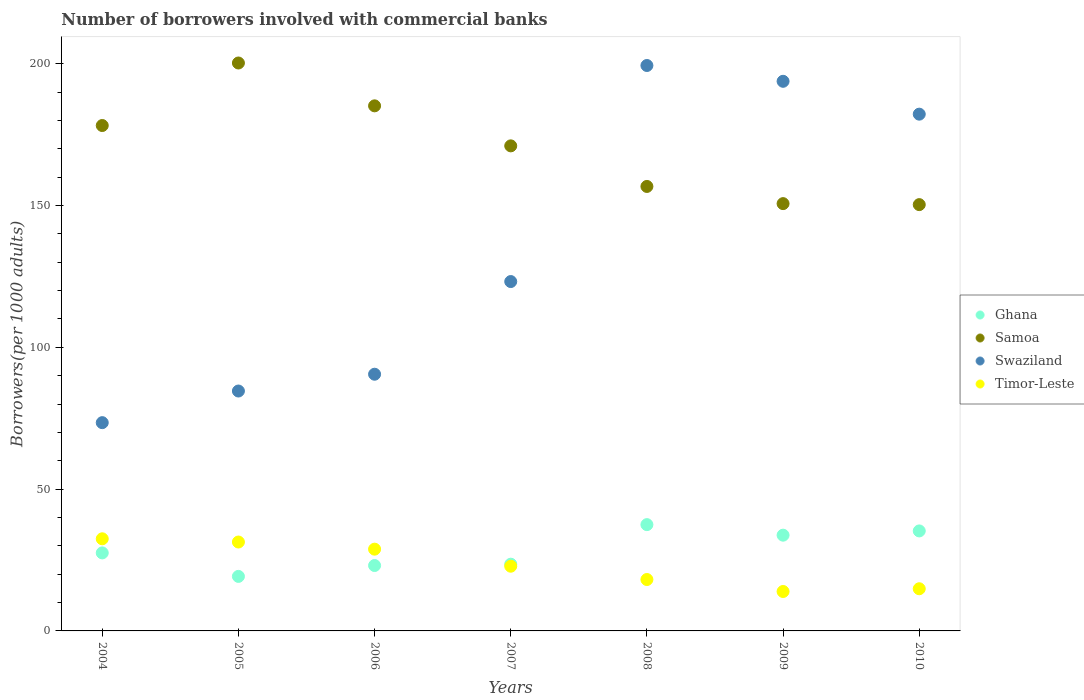How many different coloured dotlines are there?
Offer a very short reply. 4. Is the number of dotlines equal to the number of legend labels?
Give a very brief answer. Yes. What is the number of borrowers involved with commercial banks in Ghana in 2005?
Ensure brevity in your answer.  19.23. Across all years, what is the maximum number of borrowers involved with commercial banks in Timor-Leste?
Keep it short and to the point. 32.48. Across all years, what is the minimum number of borrowers involved with commercial banks in Ghana?
Your answer should be very brief. 19.23. In which year was the number of borrowers involved with commercial banks in Timor-Leste maximum?
Provide a succinct answer. 2004. What is the total number of borrowers involved with commercial banks in Swaziland in the graph?
Offer a very short reply. 947.16. What is the difference between the number of borrowers involved with commercial banks in Timor-Leste in 2005 and that in 2006?
Your answer should be compact. 2.52. What is the difference between the number of borrowers involved with commercial banks in Ghana in 2004 and the number of borrowers involved with commercial banks in Timor-Leste in 2008?
Your answer should be very brief. 9.39. What is the average number of borrowers involved with commercial banks in Timor-Leste per year?
Your answer should be very brief. 23.2. In the year 2010, what is the difference between the number of borrowers involved with commercial banks in Samoa and number of borrowers involved with commercial banks in Swaziland?
Keep it short and to the point. -31.9. In how many years, is the number of borrowers involved with commercial banks in Swaziland greater than 100?
Keep it short and to the point. 4. What is the ratio of the number of borrowers involved with commercial banks in Samoa in 2004 to that in 2010?
Provide a short and direct response. 1.19. Is the number of borrowers involved with commercial banks in Ghana in 2005 less than that in 2006?
Your answer should be compact. Yes. Is the difference between the number of borrowers involved with commercial banks in Samoa in 2007 and 2010 greater than the difference between the number of borrowers involved with commercial banks in Swaziland in 2007 and 2010?
Give a very brief answer. Yes. What is the difference between the highest and the second highest number of borrowers involved with commercial banks in Ghana?
Make the answer very short. 2.22. What is the difference between the highest and the lowest number of borrowers involved with commercial banks in Samoa?
Your answer should be very brief. 49.94. In how many years, is the number of borrowers involved with commercial banks in Swaziland greater than the average number of borrowers involved with commercial banks in Swaziland taken over all years?
Make the answer very short. 3. Is the sum of the number of borrowers involved with commercial banks in Timor-Leste in 2004 and 2010 greater than the maximum number of borrowers involved with commercial banks in Swaziland across all years?
Provide a short and direct response. No. Does the number of borrowers involved with commercial banks in Ghana monotonically increase over the years?
Your answer should be very brief. No. How many dotlines are there?
Your answer should be compact. 4. How many years are there in the graph?
Your response must be concise. 7. What is the difference between two consecutive major ticks on the Y-axis?
Provide a succinct answer. 50. Does the graph contain any zero values?
Your answer should be very brief. No. How many legend labels are there?
Give a very brief answer. 4. How are the legend labels stacked?
Your answer should be compact. Vertical. What is the title of the graph?
Keep it short and to the point. Number of borrowers involved with commercial banks. Does "Bulgaria" appear as one of the legend labels in the graph?
Your answer should be very brief. No. What is the label or title of the Y-axis?
Keep it short and to the point. Borrowers(per 1000 adults). What is the Borrowers(per 1000 adults) in Ghana in 2004?
Your answer should be very brief. 27.51. What is the Borrowers(per 1000 adults) in Samoa in 2004?
Provide a succinct answer. 178.22. What is the Borrowers(per 1000 adults) of Swaziland in 2004?
Keep it short and to the point. 73.44. What is the Borrowers(per 1000 adults) in Timor-Leste in 2004?
Provide a short and direct response. 32.48. What is the Borrowers(per 1000 adults) of Ghana in 2005?
Provide a succinct answer. 19.23. What is the Borrowers(per 1000 adults) in Samoa in 2005?
Keep it short and to the point. 200.26. What is the Borrowers(per 1000 adults) in Swaziland in 2005?
Make the answer very short. 84.59. What is the Borrowers(per 1000 adults) in Timor-Leste in 2005?
Offer a terse response. 31.35. What is the Borrowers(per 1000 adults) in Ghana in 2006?
Offer a terse response. 23.06. What is the Borrowers(per 1000 adults) in Samoa in 2006?
Provide a short and direct response. 185.16. What is the Borrowers(per 1000 adults) in Swaziland in 2006?
Ensure brevity in your answer.  90.52. What is the Borrowers(per 1000 adults) of Timor-Leste in 2006?
Give a very brief answer. 28.83. What is the Borrowers(per 1000 adults) of Ghana in 2007?
Offer a terse response. 23.53. What is the Borrowers(per 1000 adults) of Samoa in 2007?
Offer a very short reply. 171.04. What is the Borrowers(per 1000 adults) of Swaziland in 2007?
Make the answer very short. 123.19. What is the Borrowers(per 1000 adults) in Timor-Leste in 2007?
Your response must be concise. 22.82. What is the Borrowers(per 1000 adults) in Ghana in 2008?
Keep it short and to the point. 37.48. What is the Borrowers(per 1000 adults) in Samoa in 2008?
Provide a short and direct response. 156.73. What is the Borrowers(per 1000 adults) in Swaziland in 2008?
Your answer should be very brief. 199.38. What is the Borrowers(per 1000 adults) in Timor-Leste in 2008?
Your answer should be very brief. 18.13. What is the Borrowers(per 1000 adults) in Ghana in 2009?
Ensure brevity in your answer.  33.76. What is the Borrowers(per 1000 adults) in Samoa in 2009?
Ensure brevity in your answer.  150.68. What is the Borrowers(per 1000 adults) of Swaziland in 2009?
Your response must be concise. 193.81. What is the Borrowers(per 1000 adults) in Timor-Leste in 2009?
Give a very brief answer. 13.9. What is the Borrowers(per 1000 adults) of Ghana in 2010?
Make the answer very short. 35.26. What is the Borrowers(per 1000 adults) in Samoa in 2010?
Provide a short and direct response. 150.32. What is the Borrowers(per 1000 adults) in Swaziland in 2010?
Make the answer very short. 182.22. What is the Borrowers(per 1000 adults) in Timor-Leste in 2010?
Your answer should be very brief. 14.87. Across all years, what is the maximum Borrowers(per 1000 adults) of Ghana?
Your response must be concise. 37.48. Across all years, what is the maximum Borrowers(per 1000 adults) of Samoa?
Offer a terse response. 200.26. Across all years, what is the maximum Borrowers(per 1000 adults) in Swaziland?
Your response must be concise. 199.38. Across all years, what is the maximum Borrowers(per 1000 adults) in Timor-Leste?
Offer a very short reply. 32.48. Across all years, what is the minimum Borrowers(per 1000 adults) of Ghana?
Offer a terse response. 19.23. Across all years, what is the minimum Borrowers(per 1000 adults) of Samoa?
Give a very brief answer. 150.32. Across all years, what is the minimum Borrowers(per 1000 adults) of Swaziland?
Your answer should be compact. 73.44. Across all years, what is the minimum Borrowers(per 1000 adults) of Timor-Leste?
Your answer should be very brief. 13.9. What is the total Borrowers(per 1000 adults) of Ghana in the graph?
Offer a very short reply. 199.83. What is the total Borrowers(per 1000 adults) in Samoa in the graph?
Make the answer very short. 1192.41. What is the total Borrowers(per 1000 adults) of Swaziland in the graph?
Make the answer very short. 947.16. What is the total Borrowers(per 1000 adults) of Timor-Leste in the graph?
Offer a very short reply. 162.38. What is the difference between the Borrowers(per 1000 adults) in Ghana in 2004 and that in 2005?
Offer a terse response. 8.29. What is the difference between the Borrowers(per 1000 adults) of Samoa in 2004 and that in 2005?
Give a very brief answer. -22.05. What is the difference between the Borrowers(per 1000 adults) in Swaziland in 2004 and that in 2005?
Ensure brevity in your answer.  -11.15. What is the difference between the Borrowers(per 1000 adults) of Timor-Leste in 2004 and that in 2005?
Make the answer very short. 1.14. What is the difference between the Borrowers(per 1000 adults) of Ghana in 2004 and that in 2006?
Keep it short and to the point. 4.45. What is the difference between the Borrowers(per 1000 adults) of Samoa in 2004 and that in 2006?
Provide a short and direct response. -6.94. What is the difference between the Borrowers(per 1000 adults) of Swaziland in 2004 and that in 2006?
Your response must be concise. -17.08. What is the difference between the Borrowers(per 1000 adults) in Timor-Leste in 2004 and that in 2006?
Give a very brief answer. 3.65. What is the difference between the Borrowers(per 1000 adults) of Ghana in 2004 and that in 2007?
Provide a short and direct response. 3.99. What is the difference between the Borrowers(per 1000 adults) in Samoa in 2004 and that in 2007?
Offer a terse response. 7.17. What is the difference between the Borrowers(per 1000 adults) of Swaziland in 2004 and that in 2007?
Keep it short and to the point. -49.75. What is the difference between the Borrowers(per 1000 adults) in Timor-Leste in 2004 and that in 2007?
Offer a very short reply. 9.66. What is the difference between the Borrowers(per 1000 adults) of Ghana in 2004 and that in 2008?
Your answer should be very brief. -9.97. What is the difference between the Borrowers(per 1000 adults) of Samoa in 2004 and that in 2008?
Your answer should be very brief. 21.48. What is the difference between the Borrowers(per 1000 adults) of Swaziland in 2004 and that in 2008?
Provide a succinct answer. -125.94. What is the difference between the Borrowers(per 1000 adults) of Timor-Leste in 2004 and that in 2008?
Your response must be concise. 14.36. What is the difference between the Borrowers(per 1000 adults) in Ghana in 2004 and that in 2009?
Offer a very short reply. -6.25. What is the difference between the Borrowers(per 1000 adults) in Samoa in 2004 and that in 2009?
Give a very brief answer. 27.54. What is the difference between the Borrowers(per 1000 adults) in Swaziland in 2004 and that in 2009?
Your answer should be very brief. -120.37. What is the difference between the Borrowers(per 1000 adults) of Timor-Leste in 2004 and that in 2009?
Your response must be concise. 18.58. What is the difference between the Borrowers(per 1000 adults) of Ghana in 2004 and that in 2010?
Your answer should be very brief. -7.75. What is the difference between the Borrowers(per 1000 adults) in Samoa in 2004 and that in 2010?
Give a very brief answer. 27.89. What is the difference between the Borrowers(per 1000 adults) of Swaziland in 2004 and that in 2010?
Your answer should be compact. -108.78. What is the difference between the Borrowers(per 1000 adults) of Timor-Leste in 2004 and that in 2010?
Provide a succinct answer. 17.61. What is the difference between the Borrowers(per 1000 adults) in Ghana in 2005 and that in 2006?
Provide a succinct answer. -3.84. What is the difference between the Borrowers(per 1000 adults) in Samoa in 2005 and that in 2006?
Offer a very short reply. 15.11. What is the difference between the Borrowers(per 1000 adults) in Swaziland in 2005 and that in 2006?
Provide a succinct answer. -5.92. What is the difference between the Borrowers(per 1000 adults) in Timor-Leste in 2005 and that in 2006?
Offer a very short reply. 2.52. What is the difference between the Borrowers(per 1000 adults) of Ghana in 2005 and that in 2007?
Ensure brevity in your answer.  -4.3. What is the difference between the Borrowers(per 1000 adults) of Samoa in 2005 and that in 2007?
Keep it short and to the point. 29.22. What is the difference between the Borrowers(per 1000 adults) in Swaziland in 2005 and that in 2007?
Your response must be concise. -38.6. What is the difference between the Borrowers(per 1000 adults) of Timor-Leste in 2005 and that in 2007?
Your response must be concise. 8.53. What is the difference between the Borrowers(per 1000 adults) in Ghana in 2005 and that in 2008?
Make the answer very short. -18.26. What is the difference between the Borrowers(per 1000 adults) of Samoa in 2005 and that in 2008?
Offer a terse response. 43.53. What is the difference between the Borrowers(per 1000 adults) of Swaziland in 2005 and that in 2008?
Offer a very short reply. -114.79. What is the difference between the Borrowers(per 1000 adults) in Timor-Leste in 2005 and that in 2008?
Your answer should be very brief. 13.22. What is the difference between the Borrowers(per 1000 adults) in Ghana in 2005 and that in 2009?
Give a very brief answer. -14.54. What is the difference between the Borrowers(per 1000 adults) of Samoa in 2005 and that in 2009?
Provide a short and direct response. 49.59. What is the difference between the Borrowers(per 1000 adults) of Swaziland in 2005 and that in 2009?
Provide a succinct answer. -109.22. What is the difference between the Borrowers(per 1000 adults) in Timor-Leste in 2005 and that in 2009?
Give a very brief answer. 17.45. What is the difference between the Borrowers(per 1000 adults) in Ghana in 2005 and that in 2010?
Keep it short and to the point. -16.03. What is the difference between the Borrowers(per 1000 adults) in Samoa in 2005 and that in 2010?
Give a very brief answer. 49.94. What is the difference between the Borrowers(per 1000 adults) in Swaziland in 2005 and that in 2010?
Give a very brief answer. -97.63. What is the difference between the Borrowers(per 1000 adults) of Timor-Leste in 2005 and that in 2010?
Your response must be concise. 16.48. What is the difference between the Borrowers(per 1000 adults) in Ghana in 2006 and that in 2007?
Your response must be concise. -0.46. What is the difference between the Borrowers(per 1000 adults) in Samoa in 2006 and that in 2007?
Your answer should be very brief. 14.11. What is the difference between the Borrowers(per 1000 adults) in Swaziland in 2006 and that in 2007?
Your answer should be compact. -32.68. What is the difference between the Borrowers(per 1000 adults) of Timor-Leste in 2006 and that in 2007?
Ensure brevity in your answer.  6.01. What is the difference between the Borrowers(per 1000 adults) in Ghana in 2006 and that in 2008?
Provide a succinct answer. -14.42. What is the difference between the Borrowers(per 1000 adults) of Samoa in 2006 and that in 2008?
Your answer should be very brief. 28.42. What is the difference between the Borrowers(per 1000 adults) of Swaziland in 2006 and that in 2008?
Your answer should be compact. -108.86. What is the difference between the Borrowers(per 1000 adults) in Timor-Leste in 2006 and that in 2008?
Provide a short and direct response. 10.71. What is the difference between the Borrowers(per 1000 adults) in Ghana in 2006 and that in 2009?
Your answer should be compact. -10.7. What is the difference between the Borrowers(per 1000 adults) in Samoa in 2006 and that in 2009?
Provide a short and direct response. 34.48. What is the difference between the Borrowers(per 1000 adults) of Swaziland in 2006 and that in 2009?
Make the answer very short. -103.29. What is the difference between the Borrowers(per 1000 adults) in Timor-Leste in 2006 and that in 2009?
Offer a very short reply. 14.93. What is the difference between the Borrowers(per 1000 adults) in Ghana in 2006 and that in 2010?
Your answer should be very brief. -12.2. What is the difference between the Borrowers(per 1000 adults) in Samoa in 2006 and that in 2010?
Your response must be concise. 34.83. What is the difference between the Borrowers(per 1000 adults) in Swaziland in 2006 and that in 2010?
Your answer should be compact. -91.7. What is the difference between the Borrowers(per 1000 adults) in Timor-Leste in 2006 and that in 2010?
Ensure brevity in your answer.  13.96. What is the difference between the Borrowers(per 1000 adults) of Ghana in 2007 and that in 2008?
Make the answer very short. -13.96. What is the difference between the Borrowers(per 1000 adults) of Samoa in 2007 and that in 2008?
Your answer should be very brief. 14.31. What is the difference between the Borrowers(per 1000 adults) of Swaziland in 2007 and that in 2008?
Keep it short and to the point. -76.19. What is the difference between the Borrowers(per 1000 adults) of Timor-Leste in 2007 and that in 2008?
Provide a succinct answer. 4.69. What is the difference between the Borrowers(per 1000 adults) of Ghana in 2007 and that in 2009?
Your response must be concise. -10.24. What is the difference between the Borrowers(per 1000 adults) of Samoa in 2007 and that in 2009?
Provide a succinct answer. 20.37. What is the difference between the Borrowers(per 1000 adults) of Swaziland in 2007 and that in 2009?
Offer a very short reply. -70.62. What is the difference between the Borrowers(per 1000 adults) of Timor-Leste in 2007 and that in 2009?
Keep it short and to the point. 8.92. What is the difference between the Borrowers(per 1000 adults) in Ghana in 2007 and that in 2010?
Your answer should be very brief. -11.73. What is the difference between the Borrowers(per 1000 adults) in Samoa in 2007 and that in 2010?
Your answer should be very brief. 20.72. What is the difference between the Borrowers(per 1000 adults) in Swaziland in 2007 and that in 2010?
Make the answer very short. -59.03. What is the difference between the Borrowers(per 1000 adults) of Timor-Leste in 2007 and that in 2010?
Keep it short and to the point. 7.95. What is the difference between the Borrowers(per 1000 adults) in Ghana in 2008 and that in 2009?
Give a very brief answer. 3.72. What is the difference between the Borrowers(per 1000 adults) in Samoa in 2008 and that in 2009?
Provide a short and direct response. 6.06. What is the difference between the Borrowers(per 1000 adults) of Swaziland in 2008 and that in 2009?
Give a very brief answer. 5.57. What is the difference between the Borrowers(per 1000 adults) of Timor-Leste in 2008 and that in 2009?
Your answer should be compact. 4.22. What is the difference between the Borrowers(per 1000 adults) in Ghana in 2008 and that in 2010?
Keep it short and to the point. 2.22. What is the difference between the Borrowers(per 1000 adults) in Samoa in 2008 and that in 2010?
Give a very brief answer. 6.41. What is the difference between the Borrowers(per 1000 adults) of Swaziland in 2008 and that in 2010?
Offer a terse response. 17.16. What is the difference between the Borrowers(per 1000 adults) of Timor-Leste in 2008 and that in 2010?
Your answer should be very brief. 3.25. What is the difference between the Borrowers(per 1000 adults) of Ghana in 2009 and that in 2010?
Provide a succinct answer. -1.5. What is the difference between the Borrowers(per 1000 adults) of Samoa in 2009 and that in 2010?
Keep it short and to the point. 0.35. What is the difference between the Borrowers(per 1000 adults) in Swaziland in 2009 and that in 2010?
Ensure brevity in your answer.  11.59. What is the difference between the Borrowers(per 1000 adults) in Timor-Leste in 2009 and that in 2010?
Keep it short and to the point. -0.97. What is the difference between the Borrowers(per 1000 adults) in Ghana in 2004 and the Borrowers(per 1000 adults) in Samoa in 2005?
Give a very brief answer. -172.75. What is the difference between the Borrowers(per 1000 adults) of Ghana in 2004 and the Borrowers(per 1000 adults) of Swaziland in 2005?
Provide a short and direct response. -57.08. What is the difference between the Borrowers(per 1000 adults) of Ghana in 2004 and the Borrowers(per 1000 adults) of Timor-Leste in 2005?
Provide a short and direct response. -3.83. What is the difference between the Borrowers(per 1000 adults) of Samoa in 2004 and the Borrowers(per 1000 adults) of Swaziland in 2005?
Your answer should be compact. 93.62. What is the difference between the Borrowers(per 1000 adults) of Samoa in 2004 and the Borrowers(per 1000 adults) of Timor-Leste in 2005?
Provide a short and direct response. 146.87. What is the difference between the Borrowers(per 1000 adults) of Swaziland in 2004 and the Borrowers(per 1000 adults) of Timor-Leste in 2005?
Provide a short and direct response. 42.09. What is the difference between the Borrowers(per 1000 adults) of Ghana in 2004 and the Borrowers(per 1000 adults) of Samoa in 2006?
Your response must be concise. -157.64. What is the difference between the Borrowers(per 1000 adults) of Ghana in 2004 and the Borrowers(per 1000 adults) of Swaziland in 2006?
Offer a very short reply. -63. What is the difference between the Borrowers(per 1000 adults) of Ghana in 2004 and the Borrowers(per 1000 adults) of Timor-Leste in 2006?
Offer a terse response. -1.32. What is the difference between the Borrowers(per 1000 adults) in Samoa in 2004 and the Borrowers(per 1000 adults) in Swaziland in 2006?
Make the answer very short. 87.7. What is the difference between the Borrowers(per 1000 adults) in Samoa in 2004 and the Borrowers(per 1000 adults) in Timor-Leste in 2006?
Keep it short and to the point. 149.38. What is the difference between the Borrowers(per 1000 adults) of Swaziland in 2004 and the Borrowers(per 1000 adults) of Timor-Leste in 2006?
Offer a terse response. 44.61. What is the difference between the Borrowers(per 1000 adults) in Ghana in 2004 and the Borrowers(per 1000 adults) in Samoa in 2007?
Ensure brevity in your answer.  -143.53. What is the difference between the Borrowers(per 1000 adults) of Ghana in 2004 and the Borrowers(per 1000 adults) of Swaziland in 2007?
Keep it short and to the point. -95.68. What is the difference between the Borrowers(per 1000 adults) of Ghana in 2004 and the Borrowers(per 1000 adults) of Timor-Leste in 2007?
Ensure brevity in your answer.  4.69. What is the difference between the Borrowers(per 1000 adults) of Samoa in 2004 and the Borrowers(per 1000 adults) of Swaziland in 2007?
Provide a short and direct response. 55.02. What is the difference between the Borrowers(per 1000 adults) of Samoa in 2004 and the Borrowers(per 1000 adults) of Timor-Leste in 2007?
Your answer should be compact. 155.4. What is the difference between the Borrowers(per 1000 adults) of Swaziland in 2004 and the Borrowers(per 1000 adults) of Timor-Leste in 2007?
Make the answer very short. 50.62. What is the difference between the Borrowers(per 1000 adults) in Ghana in 2004 and the Borrowers(per 1000 adults) in Samoa in 2008?
Your response must be concise. -129.22. What is the difference between the Borrowers(per 1000 adults) of Ghana in 2004 and the Borrowers(per 1000 adults) of Swaziland in 2008?
Provide a succinct answer. -171.87. What is the difference between the Borrowers(per 1000 adults) in Ghana in 2004 and the Borrowers(per 1000 adults) in Timor-Leste in 2008?
Keep it short and to the point. 9.39. What is the difference between the Borrowers(per 1000 adults) of Samoa in 2004 and the Borrowers(per 1000 adults) of Swaziland in 2008?
Keep it short and to the point. -21.17. What is the difference between the Borrowers(per 1000 adults) in Samoa in 2004 and the Borrowers(per 1000 adults) in Timor-Leste in 2008?
Your answer should be very brief. 160.09. What is the difference between the Borrowers(per 1000 adults) of Swaziland in 2004 and the Borrowers(per 1000 adults) of Timor-Leste in 2008?
Provide a short and direct response. 55.31. What is the difference between the Borrowers(per 1000 adults) of Ghana in 2004 and the Borrowers(per 1000 adults) of Samoa in 2009?
Make the answer very short. -123.16. What is the difference between the Borrowers(per 1000 adults) in Ghana in 2004 and the Borrowers(per 1000 adults) in Swaziland in 2009?
Your response must be concise. -166.3. What is the difference between the Borrowers(per 1000 adults) in Ghana in 2004 and the Borrowers(per 1000 adults) in Timor-Leste in 2009?
Ensure brevity in your answer.  13.61. What is the difference between the Borrowers(per 1000 adults) in Samoa in 2004 and the Borrowers(per 1000 adults) in Swaziland in 2009?
Provide a short and direct response. -15.59. What is the difference between the Borrowers(per 1000 adults) of Samoa in 2004 and the Borrowers(per 1000 adults) of Timor-Leste in 2009?
Provide a short and direct response. 164.31. What is the difference between the Borrowers(per 1000 adults) in Swaziland in 2004 and the Borrowers(per 1000 adults) in Timor-Leste in 2009?
Ensure brevity in your answer.  59.54. What is the difference between the Borrowers(per 1000 adults) of Ghana in 2004 and the Borrowers(per 1000 adults) of Samoa in 2010?
Your answer should be very brief. -122.81. What is the difference between the Borrowers(per 1000 adults) of Ghana in 2004 and the Borrowers(per 1000 adults) of Swaziland in 2010?
Your response must be concise. -154.71. What is the difference between the Borrowers(per 1000 adults) of Ghana in 2004 and the Borrowers(per 1000 adults) of Timor-Leste in 2010?
Your response must be concise. 12.64. What is the difference between the Borrowers(per 1000 adults) of Samoa in 2004 and the Borrowers(per 1000 adults) of Swaziland in 2010?
Your answer should be very brief. -4.01. What is the difference between the Borrowers(per 1000 adults) in Samoa in 2004 and the Borrowers(per 1000 adults) in Timor-Leste in 2010?
Ensure brevity in your answer.  163.34. What is the difference between the Borrowers(per 1000 adults) in Swaziland in 2004 and the Borrowers(per 1000 adults) in Timor-Leste in 2010?
Make the answer very short. 58.57. What is the difference between the Borrowers(per 1000 adults) in Ghana in 2005 and the Borrowers(per 1000 adults) in Samoa in 2006?
Ensure brevity in your answer.  -165.93. What is the difference between the Borrowers(per 1000 adults) of Ghana in 2005 and the Borrowers(per 1000 adults) of Swaziland in 2006?
Your answer should be compact. -71.29. What is the difference between the Borrowers(per 1000 adults) in Ghana in 2005 and the Borrowers(per 1000 adults) in Timor-Leste in 2006?
Your answer should be very brief. -9.6. What is the difference between the Borrowers(per 1000 adults) of Samoa in 2005 and the Borrowers(per 1000 adults) of Swaziland in 2006?
Give a very brief answer. 109.75. What is the difference between the Borrowers(per 1000 adults) in Samoa in 2005 and the Borrowers(per 1000 adults) in Timor-Leste in 2006?
Keep it short and to the point. 171.43. What is the difference between the Borrowers(per 1000 adults) of Swaziland in 2005 and the Borrowers(per 1000 adults) of Timor-Leste in 2006?
Keep it short and to the point. 55.76. What is the difference between the Borrowers(per 1000 adults) in Ghana in 2005 and the Borrowers(per 1000 adults) in Samoa in 2007?
Give a very brief answer. -151.82. What is the difference between the Borrowers(per 1000 adults) of Ghana in 2005 and the Borrowers(per 1000 adults) of Swaziland in 2007?
Provide a succinct answer. -103.97. What is the difference between the Borrowers(per 1000 adults) in Ghana in 2005 and the Borrowers(per 1000 adults) in Timor-Leste in 2007?
Make the answer very short. -3.59. What is the difference between the Borrowers(per 1000 adults) in Samoa in 2005 and the Borrowers(per 1000 adults) in Swaziland in 2007?
Your answer should be very brief. 77.07. What is the difference between the Borrowers(per 1000 adults) of Samoa in 2005 and the Borrowers(per 1000 adults) of Timor-Leste in 2007?
Make the answer very short. 177.44. What is the difference between the Borrowers(per 1000 adults) in Swaziland in 2005 and the Borrowers(per 1000 adults) in Timor-Leste in 2007?
Ensure brevity in your answer.  61.78. What is the difference between the Borrowers(per 1000 adults) in Ghana in 2005 and the Borrowers(per 1000 adults) in Samoa in 2008?
Offer a terse response. -137.51. What is the difference between the Borrowers(per 1000 adults) of Ghana in 2005 and the Borrowers(per 1000 adults) of Swaziland in 2008?
Offer a very short reply. -180.16. What is the difference between the Borrowers(per 1000 adults) in Ghana in 2005 and the Borrowers(per 1000 adults) in Timor-Leste in 2008?
Give a very brief answer. 1.1. What is the difference between the Borrowers(per 1000 adults) of Samoa in 2005 and the Borrowers(per 1000 adults) of Swaziland in 2008?
Provide a succinct answer. 0.88. What is the difference between the Borrowers(per 1000 adults) of Samoa in 2005 and the Borrowers(per 1000 adults) of Timor-Leste in 2008?
Your answer should be compact. 182.14. What is the difference between the Borrowers(per 1000 adults) of Swaziland in 2005 and the Borrowers(per 1000 adults) of Timor-Leste in 2008?
Your response must be concise. 66.47. What is the difference between the Borrowers(per 1000 adults) in Ghana in 2005 and the Borrowers(per 1000 adults) in Samoa in 2009?
Ensure brevity in your answer.  -131.45. What is the difference between the Borrowers(per 1000 adults) in Ghana in 2005 and the Borrowers(per 1000 adults) in Swaziland in 2009?
Your response must be concise. -174.58. What is the difference between the Borrowers(per 1000 adults) of Ghana in 2005 and the Borrowers(per 1000 adults) of Timor-Leste in 2009?
Your response must be concise. 5.32. What is the difference between the Borrowers(per 1000 adults) of Samoa in 2005 and the Borrowers(per 1000 adults) of Swaziland in 2009?
Make the answer very short. 6.45. What is the difference between the Borrowers(per 1000 adults) of Samoa in 2005 and the Borrowers(per 1000 adults) of Timor-Leste in 2009?
Offer a very short reply. 186.36. What is the difference between the Borrowers(per 1000 adults) in Swaziland in 2005 and the Borrowers(per 1000 adults) in Timor-Leste in 2009?
Make the answer very short. 70.69. What is the difference between the Borrowers(per 1000 adults) of Ghana in 2005 and the Borrowers(per 1000 adults) of Samoa in 2010?
Give a very brief answer. -131.1. What is the difference between the Borrowers(per 1000 adults) of Ghana in 2005 and the Borrowers(per 1000 adults) of Swaziland in 2010?
Provide a short and direct response. -163. What is the difference between the Borrowers(per 1000 adults) of Ghana in 2005 and the Borrowers(per 1000 adults) of Timor-Leste in 2010?
Offer a terse response. 4.36. What is the difference between the Borrowers(per 1000 adults) in Samoa in 2005 and the Borrowers(per 1000 adults) in Swaziland in 2010?
Provide a short and direct response. 18.04. What is the difference between the Borrowers(per 1000 adults) in Samoa in 2005 and the Borrowers(per 1000 adults) in Timor-Leste in 2010?
Provide a succinct answer. 185.39. What is the difference between the Borrowers(per 1000 adults) in Swaziland in 2005 and the Borrowers(per 1000 adults) in Timor-Leste in 2010?
Your answer should be compact. 69.72. What is the difference between the Borrowers(per 1000 adults) in Ghana in 2006 and the Borrowers(per 1000 adults) in Samoa in 2007?
Give a very brief answer. -147.98. What is the difference between the Borrowers(per 1000 adults) in Ghana in 2006 and the Borrowers(per 1000 adults) in Swaziland in 2007?
Your answer should be compact. -100.13. What is the difference between the Borrowers(per 1000 adults) in Ghana in 2006 and the Borrowers(per 1000 adults) in Timor-Leste in 2007?
Make the answer very short. 0.24. What is the difference between the Borrowers(per 1000 adults) of Samoa in 2006 and the Borrowers(per 1000 adults) of Swaziland in 2007?
Provide a short and direct response. 61.96. What is the difference between the Borrowers(per 1000 adults) in Samoa in 2006 and the Borrowers(per 1000 adults) in Timor-Leste in 2007?
Offer a very short reply. 162.34. What is the difference between the Borrowers(per 1000 adults) in Swaziland in 2006 and the Borrowers(per 1000 adults) in Timor-Leste in 2007?
Keep it short and to the point. 67.7. What is the difference between the Borrowers(per 1000 adults) of Ghana in 2006 and the Borrowers(per 1000 adults) of Samoa in 2008?
Give a very brief answer. -133.67. What is the difference between the Borrowers(per 1000 adults) in Ghana in 2006 and the Borrowers(per 1000 adults) in Swaziland in 2008?
Give a very brief answer. -176.32. What is the difference between the Borrowers(per 1000 adults) in Ghana in 2006 and the Borrowers(per 1000 adults) in Timor-Leste in 2008?
Provide a succinct answer. 4.94. What is the difference between the Borrowers(per 1000 adults) in Samoa in 2006 and the Borrowers(per 1000 adults) in Swaziland in 2008?
Your response must be concise. -14.23. What is the difference between the Borrowers(per 1000 adults) in Samoa in 2006 and the Borrowers(per 1000 adults) in Timor-Leste in 2008?
Ensure brevity in your answer.  167.03. What is the difference between the Borrowers(per 1000 adults) of Swaziland in 2006 and the Borrowers(per 1000 adults) of Timor-Leste in 2008?
Your answer should be very brief. 72.39. What is the difference between the Borrowers(per 1000 adults) of Ghana in 2006 and the Borrowers(per 1000 adults) of Samoa in 2009?
Ensure brevity in your answer.  -127.61. What is the difference between the Borrowers(per 1000 adults) of Ghana in 2006 and the Borrowers(per 1000 adults) of Swaziland in 2009?
Offer a terse response. -170.75. What is the difference between the Borrowers(per 1000 adults) in Ghana in 2006 and the Borrowers(per 1000 adults) in Timor-Leste in 2009?
Ensure brevity in your answer.  9.16. What is the difference between the Borrowers(per 1000 adults) of Samoa in 2006 and the Borrowers(per 1000 adults) of Swaziland in 2009?
Keep it short and to the point. -8.65. What is the difference between the Borrowers(per 1000 adults) of Samoa in 2006 and the Borrowers(per 1000 adults) of Timor-Leste in 2009?
Your answer should be compact. 171.25. What is the difference between the Borrowers(per 1000 adults) in Swaziland in 2006 and the Borrowers(per 1000 adults) in Timor-Leste in 2009?
Provide a short and direct response. 76.61. What is the difference between the Borrowers(per 1000 adults) of Ghana in 2006 and the Borrowers(per 1000 adults) of Samoa in 2010?
Offer a very short reply. -127.26. What is the difference between the Borrowers(per 1000 adults) of Ghana in 2006 and the Borrowers(per 1000 adults) of Swaziland in 2010?
Provide a succinct answer. -159.16. What is the difference between the Borrowers(per 1000 adults) in Ghana in 2006 and the Borrowers(per 1000 adults) in Timor-Leste in 2010?
Your answer should be very brief. 8.19. What is the difference between the Borrowers(per 1000 adults) in Samoa in 2006 and the Borrowers(per 1000 adults) in Swaziland in 2010?
Ensure brevity in your answer.  2.93. What is the difference between the Borrowers(per 1000 adults) of Samoa in 2006 and the Borrowers(per 1000 adults) of Timor-Leste in 2010?
Provide a short and direct response. 170.28. What is the difference between the Borrowers(per 1000 adults) of Swaziland in 2006 and the Borrowers(per 1000 adults) of Timor-Leste in 2010?
Your answer should be very brief. 75.65. What is the difference between the Borrowers(per 1000 adults) of Ghana in 2007 and the Borrowers(per 1000 adults) of Samoa in 2008?
Your answer should be very brief. -133.21. What is the difference between the Borrowers(per 1000 adults) in Ghana in 2007 and the Borrowers(per 1000 adults) in Swaziland in 2008?
Ensure brevity in your answer.  -175.86. What is the difference between the Borrowers(per 1000 adults) in Ghana in 2007 and the Borrowers(per 1000 adults) in Timor-Leste in 2008?
Make the answer very short. 5.4. What is the difference between the Borrowers(per 1000 adults) of Samoa in 2007 and the Borrowers(per 1000 adults) of Swaziland in 2008?
Your answer should be very brief. -28.34. What is the difference between the Borrowers(per 1000 adults) in Samoa in 2007 and the Borrowers(per 1000 adults) in Timor-Leste in 2008?
Ensure brevity in your answer.  152.92. What is the difference between the Borrowers(per 1000 adults) in Swaziland in 2007 and the Borrowers(per 1000 adults) in Timor-Leste in 2008?
Ensure brevity in your answer.  105.07. What is the difference between the Borrowers(per 1000 adults) in Ghana in 2007 and the Borrowers(per 1000 adults) in Samoa in 2009?
Provide a succinct answer. -127.15. What is the difference between the Borrowers(per 1000 adults) of Ghana in 2007 and the Borrowers(per 1000 adults) of Swaziland in 2009?
Give a very brief answer. -170.28. What is the difference between the Borrowers(per 1000 adults) in Ghana in 2007 and the Borrowers(per 1000 adults) in Timor-Leste in 2009?
Your answer should be compact. 9.62. What is the difference between the Borrowers(per 1000 adults) of Samoa in 2007 and the Borrowers(per 1000 adults) of Swaziland in 2009?
Your answer should be very brief. -22.77. What is the difference between the Borrowers(per 1000 adults) in Samoa in 2007 and the Borrowers(per 1000 adults) in Timor-Leste in 2009?
Your answer should be very brief. 157.14. What is the difference between the Borrowers(per 1000 adults) in Swaziland in 2007 and the Borrowers(per 1000 adults) in Timor-Leste in 2009?
Your answer should be compact. 109.29. What is the difference between the Borrowers(per 1000 adults) in Ghana in 2007 and the Borrowers(per 1000 adults) in Samoa in 2010?
Your response must be concise. -126.8. What is the difference between the Borrowers(per 1000 adults) of Ghana in 2007 and the Borrowers(per 1000 adults) of Swaziland in 2010?
Make the answer very short. -158.69. What is the difference between the Borrowers(per 1000 adults) in Ghana in 2007 and the Borrowers(per 1000 adults) in Timor-Leste in 2010?
Offer a terse response. 8.66. What is the difference between the Borrowers(per 1000 adults) in Samoa in 2007 and the Borrowers(per 1000 adults) in Swaziland in 2010?
Provide a short and direct response. -11.18. What is the difference between the Borrowers(per 1000 adults) in Samoa in 2007 and the Borrowers(per 1000 adults) in Timor-Leste in 2010?
Ensure brevity in your answer.  156.17. What is the difference between the Borrowers(per 1000 adults) of Swaziland in 2007 and the Borrowers(per 1000 adults) of Timor-Leste in 2010?
Provide a short and direct response. 108.32. What is the difference between the Borrowers(per 1000 adults) in Ghana in 2008 and the Borrowers(per 1000 adults) in Samoa in 2009?
Your answer should be very brief. -113.19. What is the difference between the Borrowers(per 1000 adults) of Ghana in 2008 and the Borrowers(per 1000 adults) of Swaziland in 2009?
Offer a terse response. -156.33. What is the difference between the Borrowers(per 1000 adults) in Ghana in 2008 and the Borrowers(per 1000 adults) in Timor-Leste in 2009?
Give a very brief answer. 23.58. What is the difference between the Borrowers(per 1000 adults) in Samoa in 2008 and the Borrowers(per 1000 adults) in Swaziland in 2009?
Offer a very short reply. -37.08. What is the difference between the Borrowers(per 1000 adults) in Samoa in 2008 and the Borrowers(per 1000 adults) in Timor-Leste in 2009?
Your answer should be compact. 142.83. What is the difference between the Borrowers(per 1000 adults) of Swaziland in 2008 and the Borrowers(per 1000 adults) of Timor-Leste in 2009?
Provide a succinct answer. 185.48. What is the difference between the Borrowers(per 1000 adults) of Ghana in 2008 and the Borrowers(per 1000 adults) of Samoa in 2010?
Your answer should be very brief. -112.84. What is the difference between the Borrowers(per 1000 adults) of Ghana in 2008 and the Borrowers(per 1000 adults) of Swaziland in 2010?
Ensure brevity in your answer.  -144.74. What is the difference between the Borrowers(per 1000 adults) in Ghana in 2008 and the Borrowers(per 1000 adults) in Timor-Leste in 2010?
Keep it short and to the point. 22.61. What is the difference between the Borrowers(per 1000 adults) in Samoa in 2008 and the Borrowers(per 1000 adults) in Swaziland in 2010?
Keep it short and to the point. -25.49. What is the difference between the Borrowers(per 1000 adults) in Samoa in 2008 and the Borrowers(per 1000 adults) in Timor-Leste in 2010?
Make the answer very short. 141.86. What is the difference between the Borrowers(per 1000 adults) in Swaziland in 2008 and the Borrowers(per 1000 adults) in Timor-Leste in 2010?
Ensure brevity in your answer.  184.51. What is the difference between the Borrowers(per 1000 adults) in Ghana in 2009 and the Borrowers(per 1000 adults) in Samoa in 2010?
Provide a succinct answer. -116.56. What is the difference between the Borrowers(per 1000 adults) of Ghana in 2009 and the Borrowers(per 1000 adults) of Swaziland in 2010?
Your answer should be compact. -148.46. What is the difference between the Borrowers(per 1000 adults) of Ghana in 2009 and the Borrowers(per 1000 adults) of Timor-Leste in 2010?
Provide a short and direct response. 18.89. What is the difference between the Borrowers(per 1000 adults) in Samoa in 2009 and the Borrowers(per 1000 adults) in Swaziland in 2010?
Provide a succinct answer. -31.55. What is the difference between the Borrowers(per 1000 adults) of Samoa in 2009 and the Borrowers(per 1000 adults) of Timor-Leste in 2010?
Give a very brief answer. 135.81. What is the difference between the Borrowers(per 1000 adults) in Swaziland in 2009 and the Borrowers(per 1000 adults) in Timor-Leste in 2010?
Your response must be concise. 178.94. What is the average Borrowers(per 1000 adults) in Ghana per year?
Give a very brief answer. 28.55. What is the average Borrowers(per 1000 adults) in Samoa per year?
Offer a very short reply. 170.34. What is the average Borrowers(per 1000 adults) of Swaziland per year?
Your response must be concise. 135.31. What is the average Borrowers(per 1000 adults) in Timor-Leste per year?
Your answer should be compact. 23.2. In the year 2004, what is the difference between the Borrowers(per 1000 adults) in Ghana and Borrowers(per 1000 adults) in Samoa?
Provide a succinct answer. -150.7. In the year 2004, what is the difference between the Borrowers(per 1000 adults) in Ghana and Borrowers(per 1000 adults) in Swaziland?
Offer a terse response. -45.93. In the year 2004, what is the difference between the Borrowers(per 1000 adults) of Ghana and Borrowers(per 1000 adults) of Timor-Leste?
Your response must be concise. -4.97. In the year 2004, what is the difference between the Borrowers(per 1000 adults) of Samoa and Borrowers(per 1000 adults) of Swaziland?
Give a very brief answer. 104.78. In the year 2004, what is the difference between the Borrowers(per 1000 adults) in Samoa and Borrowers(per 1000 adults) in Timor-Leste?
Keep it short and to the point. 145.73. In the year 2004, what is the difference between the Borrowers(per 1000 adults) of Swaziland and Borrowers(per 1000 adults) of Timor-Leste?
Your answer should be very brief. 40.96. In the year 2005, what is the difference between the Borrowers(per 1000 adults) in Ghana and Borrowers(per 1000 adults) in Samoa?
Offer a terse response. -181.04. In the year 2005, what is the difference between the Borrowers(per 1000 adults) in Ghana and Borrowers(per 1000 adults) in Swaziland?
Your answer should be compact. -65.37. In the year 2005, what is the difference between the Borrowers(per 1000 adults) of Ghana and Borrowers(per 1000 adults) of Timor-Leste?
Provide a succinct answer. -12.12. In the year 2005, what is the difference between the Borrowers(per 1000 adults) of Samoa and Borrowers(per 1000 adults) of Swaziland?
Keep it short and to the point. 115.67. In the year 2005, what is the difference between the Borrowers(per 1000 adults) of Samoa and Borrowers(per 1000 adults) of Timor-Leste?
Your response must be concise. 168.91. In the year 2005, what is the difference between the Borrowers(per 1000 adults) in Swaziland and Borrowers(per 1000 adults) in Timor-Leste?
Give a very brief answer. 53.25. In the year 2006, what is the difference between the Borrowers(per 1000 adults) in Ghana and Borrowers(per 1000 adults) in Samoa?
Your response must be concise. -162.09. In the year 2006, what is the difference between the Borrowers(per 1000 adults) in Ghana and Borrowers(per 1000 adults) in Swaziland?
Offer a terse response. -67.45. In the year 2006, what is the difference between the Borrowers(per 1000 adults) in Ghana and Borrowers(per 1000 adults) in Timor-Leste?
Make the answer very short. -5.77. In the year 2006, what is the difference between the Borrowers(per 1000 adults) in Samoa and Borrowers(per 1000 adults) in Swaziland?
Offer a very short reply. 94.64. In the year 2006, what is the difference between the Borrowers(per 1000 adults) of Samoa and Borrowers(per 1000 adults) of Timor-Leste?
Offer a terse response. 156.32. In the year 2006, what is the difference between the Borrowers(per 1000 adults) in Swaziland and Borrowers(per 1000 adults) in Timor-Leste?
Provide a succinct answer. 61.69. In the year 2007, what is the difference between the Borrowers(per 1000 adults) of Ghana and Borrowers(per 1000 adults) of Samoa?
Make the answer very short. -147.52. In the year 2007, what is the difference between the Borrowers(per 1000 adults) of Ghana and Borrowers(per 1000 adults) of Swaziland?
Provide a succinct answer. -99.67. In the year 2007, what is the difference between the Borrowers(per 1000 adults) of Ghana and Borrowers(per 1000 adults) of Timor-Leste?
Keep it short and to the point. 0.71. In the year 2007, what is the difference between the Borrowers(per 1000 adults) of Samoa and Borrowers(per 1000 adults) of Swaziland?
Your response must be concise. 47.85. In the year 2007, what is the difference between the Borrowers(per 1000 adults) of Samoa and Borrowers(per 1000 adults) of Timor-Leste?
Provide a short and direct response. 148.22. In the year 2007, what is the difference between the Borrowers(per 1000 adults) of Swaziland and Borrowers(per 1000 adults) of Timor-Leste?
Make the answer very short. 100.37. In the year 2008, what is the difference between the Borrowers(per 1000 adults) of Ghana and Borrowers(per 1000 adults) of Samoa?
Make the answer very short. -119.25. In the year 2008, what is the difference between the Borrowers(per 1000 adults) in Ghana and Borrowers(per 1000 adults) in Swaziland?
Your response must be concise. -161.9. In the year 2008, what is the difference between the Borrowers(per 1000 adults) of Ghana and Borrowers(per 1000 adults) of Timor-Leste?
Your answer should be very brief. 19.36. In the year 2008, what is the difference between the Borrowers(per 1000 adults) in Samoa and Borrowers(per 1000 adults) in Swaziland?
Provide a succinct answer. -42.65. In the year 2008, what is the difference between the Borrowers(per 1000 adults) in Samoa and Borrowers(per 1000 adults) in Timor-Leste?
Ensure brevity in your answer.  138.61. In the year 2008, what is the difference between the Borrowers(per 1000 adults) of Swaziland and Borrowers(per 1000 adults) of Timor-Leste?
Ensure brevity in your answer.  181.26. In the year 2009, what is the difference between the Borrowers(per 1000 adults) of Ghana and Borrowers(per 1000 adults) of Samoa?
Keep it short and to the point. -116.91. In the year 2009, what is the difference between the Borrowers(per 1000 adults) in Ghana and Borrowers(per 1000 adults) in Swaziland?
Ensure brevity in your answer.  -160.05. In the year 2009, what is the difference between the Borrowers(per 1000 adults) in Ghana and Borrowers(per 1000 adults) in Timor-Leste?
Give a very brief answer. 19.86. In the year 2009, what is the difference between the Borrowers(per 1000 adults) in Samoa and Borrowers(per 1000 adults) in Swaziland?
Give a very brief answer. -43.13. In the year 2009, what is the difference between the Borrowers(per 1000 adults) of Samoa and Borrowers(per 1000 adults) of Timor-Leste?
Your answer should be very brief. 136.77. In the year 2009, what is the difference between the Borrowers(per 1000 adults) of Swaziland and Borrowers(per 1000 adults) of Timor-Leste?
Your response must be concise. 179.91. In the year 2010, what is the difference between the Borrowers(per 1000 adults) in Ghana and Borrowers(per 1000 adults) in Samoa?
Make the answer very short. -115.06. In the year 2010, what is the difference between the Borrowers(per 1000 adults) in Ghana and Borrowers(per 1000 adults) in Swaziland?
Make the answer very short. -146.96. In the year 2010, what is the difference between the Borrowers(per 1000 adults) in Ghana and Borrowers(per 1000 adults) in Timor-Leste?
Your answer should be very brief. 20.39. In the year 2010, what is the difference between the Borrowers(per 1000 adults) in Samoa and Borrowers(per 1000 adults) in Swaziland?
Make the answer very short. -31.9. In the year 2010, what is the difference between the Borrowers(per 1000 adults) in Samoa and Borrowers(per 1000 adults) in Timor-Leste?
Make the answer very short. 135.45. In the year 2010, what is the difference between the Borrowers(per 1000 adults) in Swaziland and Borrowers(per 1000 adults) in Timor-Leste?
Provide a succinct answer. 167.35. What is the ratio of the Borrowers(per 1000 adults) of Ghana in 2004 to that in 2005?
Provide a short and direct response. 1.43. What is the ratio of the Borrowers(per 1000 adults) of Samoa in 2004 to that in 2005?
Provide a short and direct response. 0.89. What is the ratio of the Borrowers(per 1000 adults) in Swaziland in 2004 to that in 2005?
Provide a short and direct response. 0.87. What is the ratio of the Borrowers(per 1000 adults) in Timor-Leste in 2004 to that in 2005?
Offer a very short reply. 1.04. What is the ratio of the Borrowers(per 1000 adults) of Ghana in 2004 to that in 2006?
Offer a terse response. 1.19. What is the ratio of the Borrowers(per 1000 adults) of Samoa in 2004 to that in 2006?
Your answer should be very brief. 0.96. What is the ratio of the Borrowers(per 1000 adults) in Swaziland in 2004 to that in 2006?
Provide a short and direct response. 0.81. What is the ratio of the Borrowers(per 1000 adults) in Timor-Leste in 2004 to that in 2006?
Your answer should be very brief. 1.13. What is the ratio of the Borrowers(per 1000 adults) in Ghana in 2004 to that in 2007?
Your response must be concise. 1.17. What is the ratio of the Borrowers(per 1000 adults) in Samoa in 2004 to that in 2007?
Your response must be concise. 1.04. What is the ratio of the Borrowers(per 1000 adults) of Swaziland in 2004 to that in 2007?
Provide a succinct answer. 0.6. What is the ratio of the Borrowers(per 1000 adults) of Timor-Leste in 2004 to that in 2007?
Your answer should be very brief. 1.42. What is the ratio of the Borrowers(per 1000 adults) of Ghana in 2004 to that in 2008?
Make the answer very short. 0.73. What is the ratio of the Borrowers(per 1000 adults) of Samoa in 2004 to that in 2008?
Offer a terse response. 1.14. What is the ratio of the Borrowers(per 1000 adults) in Swaziland in 2004 to that in 2008?
Offer a terse response. 0.37. What is the ratio of the Borrowers(per 1000 adults) in Timor-Leste in 2004 to that in 2008?
Ensure brevity in your answer.  1.79. What is the ratio of the Borrowers(per 1000 adults) in Ghana in 2004 to that in 2009?
Your answer should be very brief. 0.81. What is the ratio of the Borrowers(per 1000 adults) in Samoa in 2004 to that in 2009?
Your response must be concise. 1.18. What is the ratio of the Borrowers(per 1000 adults) in Swaziland in 2004 to that in 2009?
Provide a short and direct response. 0.38. What is the ratio of the Borrowers(per 1000 adults) of Timor-Leste in 2004 to that in 2009?
Your answer should be very brief. 2.34. What is the ratio of the Borrowers(per 1000 adults) in Ghana in 2004 to that in 2010?
Provide a short and direct response. 0.78. What is the ratio of the Borrowers(per 1000 adults) of Samoa in 2004 to that in 2010?
Your response must be concise. 1.19. What is the ratio of the Borrowers(per 1000 adults) in Swaziland in 2004 to that in 2010?
Your answer should be compact. 0.4. What is the ratio of the Borrowers(per 1000 adults) in Timor-Leste in 2004 to that in 2010?
Provide a succinct answer. 2.18. What is the ratio of the Borrowers(per 1000 adults) in Ghana in 2005 to that in 2006?
Offer a terse response. 0.83. What is the ratio of the Borrowers(per 1000 adults) in Samoa in 2005 to that in 2006?
Your answer should be very brief. 1.08. What is the ratio of the Borrowers(per 1000 adults) in Swaziland in 2005 to that in 2006?
Keep it short and to the point. 0.93. What is the ratio of the Borrowers(per 1000 adults) in Timor-Leste in 2005 to that in 2006?
Your answer should be compact. 1.09. What is the ratio of the Borrowers(per 1000 adults) of Ghana in 2005 to that in 2007?
Provide a short and direct response. 0.82. What is the ratio of the Borrowers(per 1000 adults) in Samoa in 2005 to that in 2007?
Your answer should be very brief. 1.17. What is the ratio of the Borrowers(per 1000 adults) of Swaziland in 2005 to that in 2007?
Give a very brief answer. 0.69. What is the ratio of the Borrowers(per 1000 adults) of Timor-Leste in 2005 to that in 2007?
Give a very brief answer. 1.37. What is the ratio of the Borrowers(per 1000 adults) of Ghana in 2005 to that in 2008?
Offer a very short reply. 0.51. What is the ratio of the Borrowers(per 1000 adults) in Samoa in 2005 to that in 2008?
Keep it short and to the point. 1.28. What is the ratio of the Borrowers(per 1000 adults) in Swaziland in 2005 to that in 2008?
Your answer should be very brief. 0.42. What is the ratio of the Borrowers(per 1000 adults) of Timor-Leste in 2005 to that in 2008?
Ensure brevity in your answer.  1.73. What is the ratio of the Borrowers(per 1000 adults) of Ghana in 2005 to that in 2009?
Offer a very short reply. 0.57. What is the ratio of the Borrowers(per 1000 adults) in Samoa in 2005 to that in 2009?
Your response must be concise. 1.33. What is the ratio of the Borrowers(per 1000 adults) of Swaziland in 2005 to that in 2009?
Your answer should be compact. 0.44. What is the ratio of the Borrowers(per 1000 adults) of Timor-Leste in 2005 to that in 2009?
Your answer should be very brief. 2.25. What is the ratio of the Borrowers(per 1000 adults) in Ghana in 2005 to that in 2010?
Give a very brief answer. 0.55. What is the ratio of the Borrowers(per 1000 adults) of Samoa in 2005 to that in 2010?
Ensure brevity in your answer.  1.33. What is the ratio of the Borrowers(per 1000 adults) in Swaziland in 2005 to that in 2010?
Offer a terse response. 0.46. What is the ratio of the Borrowers(per 1000 adults) of Timor-Leste in 2005 to that in 2010?
Keep it short and to the point. 2.11. What is the ratio of the Borrowers(per 1000 adults) in Ghana in 2006 to that in 2007?
Offer a terse response. 0.98. What is the ratio of the Borrowers(per 1000 adults) in Samoa in 2006 to that in 2007?
Your answer should be very brief. 1.08. What is the ratio of the Borrowers(per 1000 adults) in Swaziland in 2006 to that in 2007?
Give a very brief answer. 0.73. What is the ratio of the Borrowers(per 1000 adults) of Timor-Leste in 2006 to that in 2007?
Ensure brevity in your answer.  1.26. What is the ratio of the Borrowers(per 1000 adults) of Ghana in 2006 to that in 2008?
Your answer should be very brief. 0.62. What is the ratio of the Borrowers(per 1000 adults) of Samoa in 2006 to that in 2008?
Give a very brief answer. 1.18. What is the ratio of the Borrowers(per 1000 adults) of Swaziland in 2006 to that in 2008?
Keep it short and to the point. 0.45. What is the ratio of the Borrowers(per 1000 adults) of Timor-Leste in 2006 to that in 2008?
Provide a short and direct response. 1.59. What is the ratio of the Borrowers(per 1000 adults) in Ghana in 2006 to that in 2009?
Give a very brief answer. 0.68. What is the ratio of the Borrowers(per 1000 adults) in Samoa in 2006 to that in 2009?
Ensure brevity in your answer.  1.23. What is the ratio of the Borrowers(per 1000 adults) in Swaziland in 2006 to that in 2009?
Give a very brief answer. 0.47. What is the ratio of the Borrowers(per 1000 adults) of Timor-Leste in 2006 to that in 2009?
Offer a very short reply. 2.07. What is the ratio of the Borrowers(per 1000 adults) of Ghana in 2006 to that in 2010?
Provide a short and direct response. 0.65. What is the ratio of the Borrowers(per 1000 adults) in Samoa in 2006 to that in 2010?
Provide a succinct answer. 1.23. What is the ratio of the Borrowers(per 1000 adults) of Swaziland in 2006 to that in 2010?
Ensure brevity in your answer.  0.5. What is the ratio of the Borrowers(per 1000 adults) of Timor-Leste in 2006 to that in 2010?
Ensure brevity in your answer.  1.94. What is the ratio of the Borrowers(per 1000 adults) in Ghana in 2007 to that in 2008?
Provide a succinct answer. 0.63. What is the ratio of the Borrowers(per 1000 adults) in Samoa in 2007 to that in 2008?
Offer a terse response. 1.09. What is the ratio of the Borrowers(per 1000 adults) in Swaziland in 2007 to that in 2008?
Your answer should be compact. 0.62. What is the ratio of the Borrowers(per 1000 adults) of Timor-Leste in 2007 to that in 2008?
Your response must be concise. 1.26. What is the ratio of the Borrowers(per 1000 adults) of Ghana in 2007 to that in 2009?
Make the answer very short. 0.7. What is the ratio of the Borrowers(per 1000 adults) of Samoa in 2007 to that in 2009?
Provide a succinct answer. 1.14. What is the ratio of the Borrowers(per 1000 adults) of Swaziland in 2007 to that in 2009?
Offer a terse response. 0.64. What is the ratio of the Borrowers(per 1000 adults) of Timor-Leste in 2007 to that in 2009?
Your response must be concise. 1.64. What is the ratio of the Borrowers(per 1000 adults) of Ghana in 2007 to that in 2010?
Your answer should be compact. 0.67. What is the ratio of the Borrowers(per 1000 adults) in Samoa in 2007 to that in 2010?
Provide a succinct answer. 1.14. What is the ratio of the Borrowers(per 1000 adults) in Swaziland in 2007 to that in 2010?
Offer a very short reply. 0.68. What is the ratio of the Borrowers(per 1000 adults) in Timor-Leste in 2007 to that in 2010?
Offer a terse response. 1.53. What is the ratio of the Borrowers(per 1000 adults) in Ghana in 2008 to that in 2009?
Offer a very short reply. 1.11. What is the ratio of the Borrowers(per 1000 adults) of Samoa in 2008 to that in 2009?
Ensure brevity in your answer.  1.04. What is the ratio of the Borrowers(per 1000 adults) of Swaziland in 2008 to that in 2009?
Your answer should be compact. 1.03. What is the ratio of the Borrowers(per 1000 adults) of Timor-Leste in 2008 to that in 2009?
Ensure brevity in your answer.  1.3. What is the ratio of the Borrowers(per 1000 adults) of Ghana in 2008 to that in 2010?
Provide a succinct answer. 1.06. What is the ratio of the Borrowers(per 1000 adults) of Samoa in 2008 to that in 2010?
Offer a terse response. 1.04. What is the ratio of the Borrowers(per 1000 adults) in Swaziland in 2008 to that in 2010?
Your answer should be very brief. 1.09. What is the ratio of the Borrowers(per 1000 adults) in Timor-Leste in 2008 to that in 2010?
Offer a very short reply. 1.22. What is the ratio of the Borrowers(per 1000 adults) in Ghana in 2009 to that in 2010?
Ensure brevity in your answer.  0.96. What is the ratio of the Borrowers(per 1000 adults) in Swaziland in 2009 to that in 2010?
Make the answer very short. 1.06. What is the ratio of the Borrowers(per 1000 adults) of Timor-Leste in 2009 to that in 2010?
Offer a very short reply. 0.94. What is the difference between the highest and the second highest Borrowers(per 1000 adults) in Ghana?
Your response must be concise. 2.22. What is the difference between the highest and the second highest Borrowers(per 1000 adults) of Samoa?
Ensure brevity in your answer.  15.11. What is the difference between the highest and the second highest Borrowers(per 1000 adults) in Swaziland?
Provide a succinct answer. 5.57. What is the difference between the highest and the second highest Borrowers(per 1000 adults) in Timor-Leste?
Your answer should be very brief. 1.14. What is the difference between the highest and the lowest Borrowers(per 1000 adults) of Ghana?
Offer a terse response. 18.26. What is the difference between the highest and the lowest Borrowers(per 1000 adults) in Samoa?
Your answer should be compact. 49.94. What is the difference between the highest and the lowest Borrowers(per 1000 adults) in Swaziland?
Keep it short and to the point. 125.94. What is the difference between the highest and the lowest Borrowers(per 1000 adults) of Timor-Leste?
Your answer should be very brief. 18.58. 